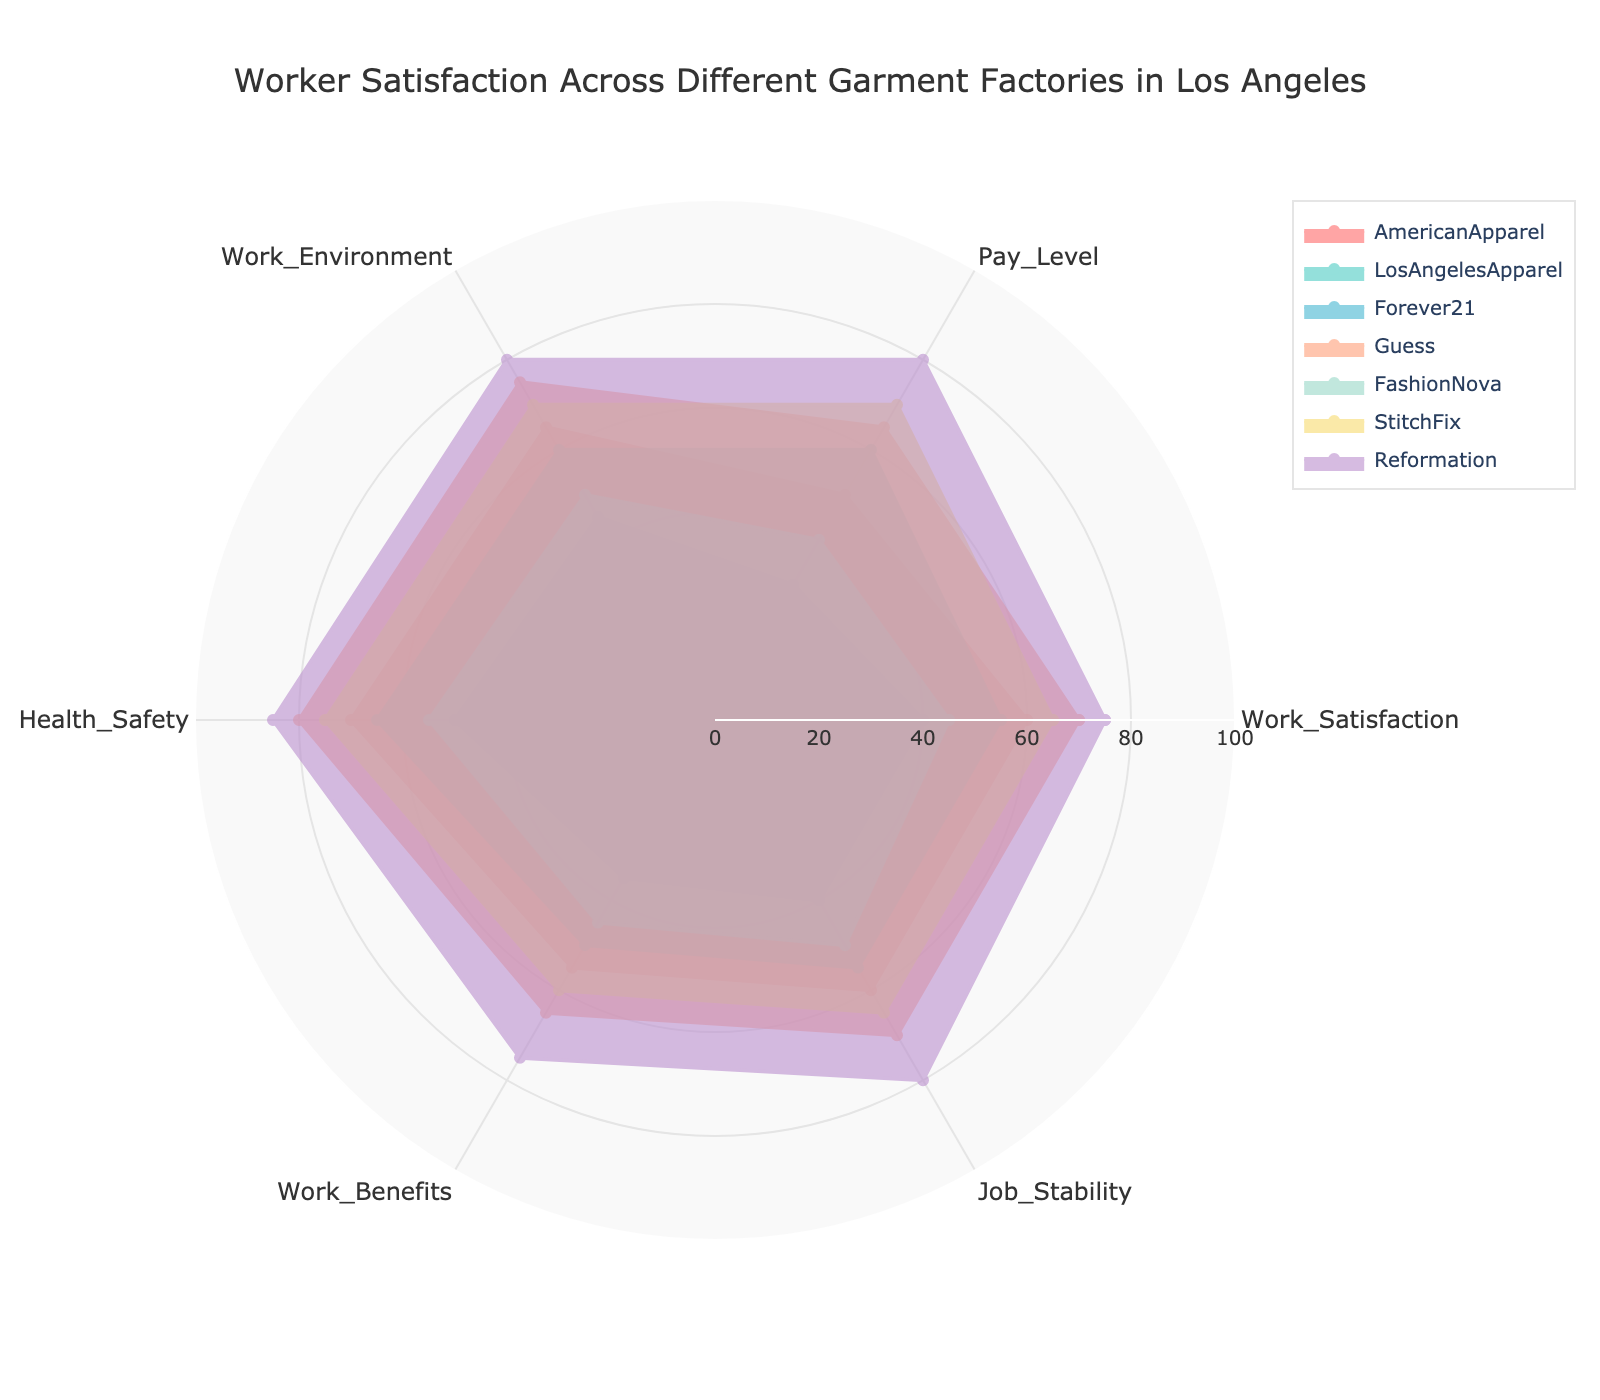How many factories are compared in the radar chart? There are seven distinct traces in the radar chart, each representing a different factory: American Apparel, Los Angeles Apparel, Forever 21, Guess, Fashion Nova, Stitch Fix, and Reformation.
Answer: 7 Which factory has the highest Overall Work Satisfaction? By looking at the section for Work Satisfaction, Reformation has the highest value, indicated by the largest extension in that category.
Answer: Reformation How does Forever 21's Pay Level compare to Guess's Pay Level? Forever 21 has a Pay Level score of 30, while Guess has a Pay Level score of 65. Comparing these two, Guess has a higher Pay Level.
Answer: Guess What is the average Health and Safety score for Reformation and Stitch Fix? Reformation has a Health and Safety score of 85, and Stitch Fix has a score of 75. Summing these gives 85 + 75 = 160. The average is 160 / 2 = 80.
Answer: 80 Which factory has the most balanced scores across all categories? A balanced score means less variation between the categories. By visually inspecting the radar chart, Reformation appears to have the most balanced scores, with relatively high and consistent values across all categories.
Answer: Reformation Where does Fashion Nova rank in Work Environment compared to American Apparel and Stitch Fix? Fashion Nova has a Work Environment score of 50, whereas American Apparel has 65 and Stitch Fix has 70 in that category. Fashion Nova ranks the lowest among the three.
Answer: Lowest Which category has the widest range of scores across all factories? By observing the differences in the radar chart sectors, Pay Level shows a significant range from 30 (Forever 21) to 80 (Reformation), indicating the widest range of scores.
Answer: Pay Level What is the sum of Job Stability scores for American Apparel and Fashion Nova? American Apparel has a Job Stability score of 60 and Fashion Nova has 50. Adding these together gives 60 + 50 = 110.
Answer: 110 In the category of Work Benefits, which factory scores the highest and by how much does it surpass the lowest-scoring factory? Reformation scores the highest in Work Benefits with 75 while Forever 21 scores the lowest with 35. The difference is 75 - 35 = 40.
Answer: Reformation, 40 